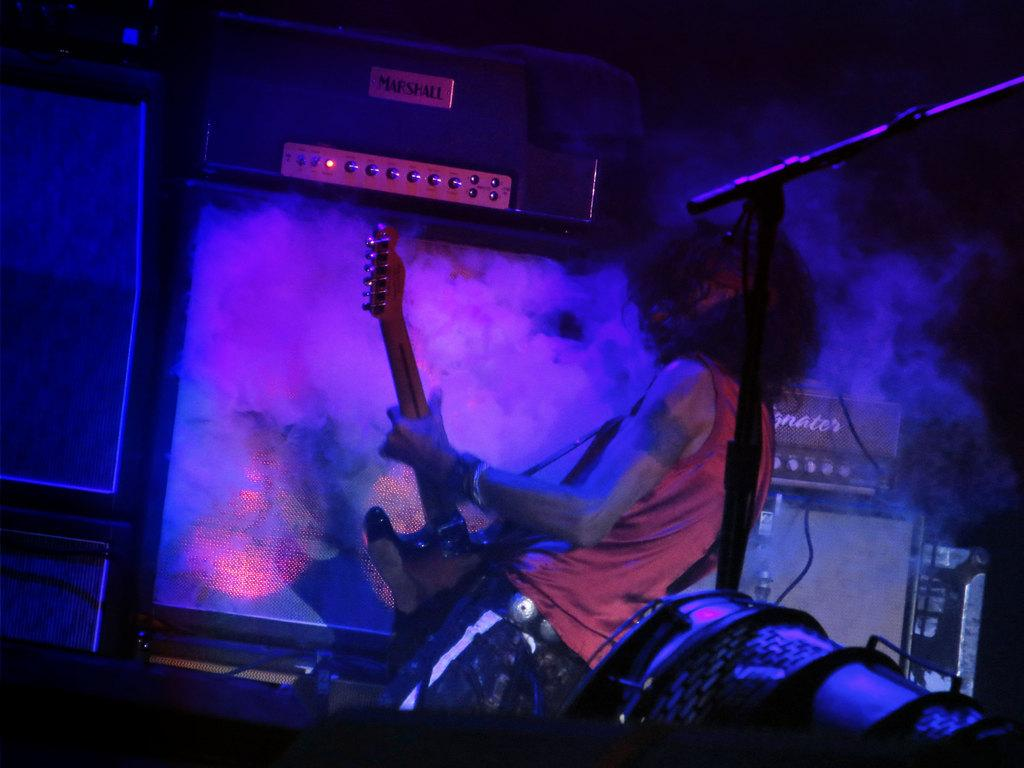Who is the main subject in the image? There is a man in the image. What is the man doing in the image? The man is standing and playing a guitar. What can be seen in the background of the image? There is smoke in the background of the image. What time of day is it in the image? The time of day cannot be determined from the image, as there are no clues or indicators of time. 